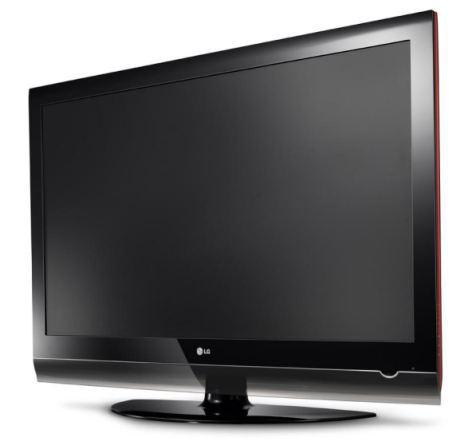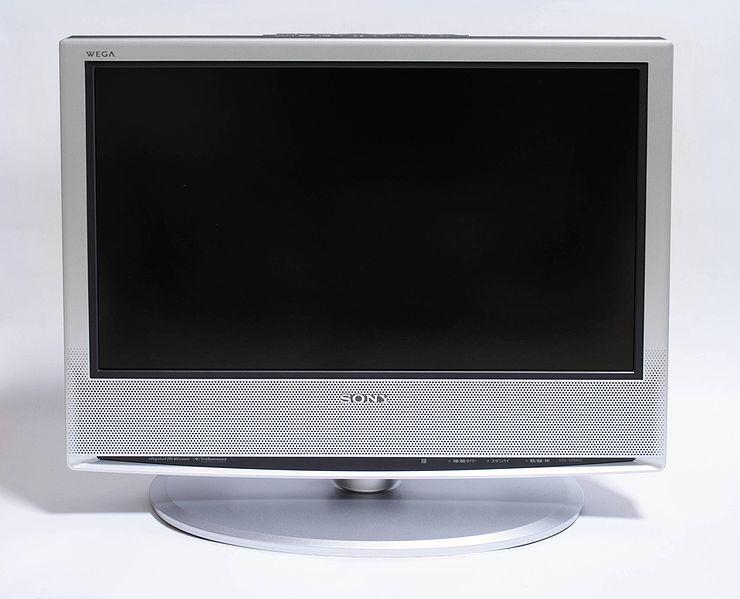The first image is the image on the left, the second image is the image on the right. Assess this claim about the two images: "The left and right image contains the same number of computer monitors with one being silver.". Correct or not? Answer yes or no. Yes. The first image is the image on the left, the second image is the image on the right. For the images shown, is this caption "Each image contains exactly one upright TV on a stand, and one image depicts a TV head-on, while the other image depicts a TV at an angle." true? Answer yes or no. Yes. 